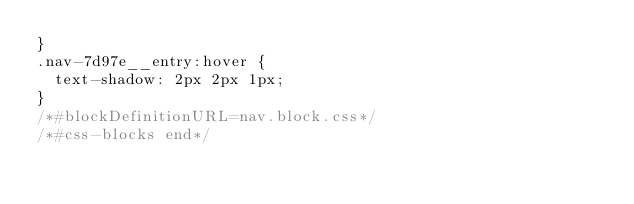<code> <loc_0><loc_0><loc_500><loc_500><_CSS_>}
.nav-7d97e__entry:hover {
  text-shadow: 2px 2px 1px;
}
/*#blockDefinitionURL=nav.block.css*/
/*#css-blocks end*/</code> 